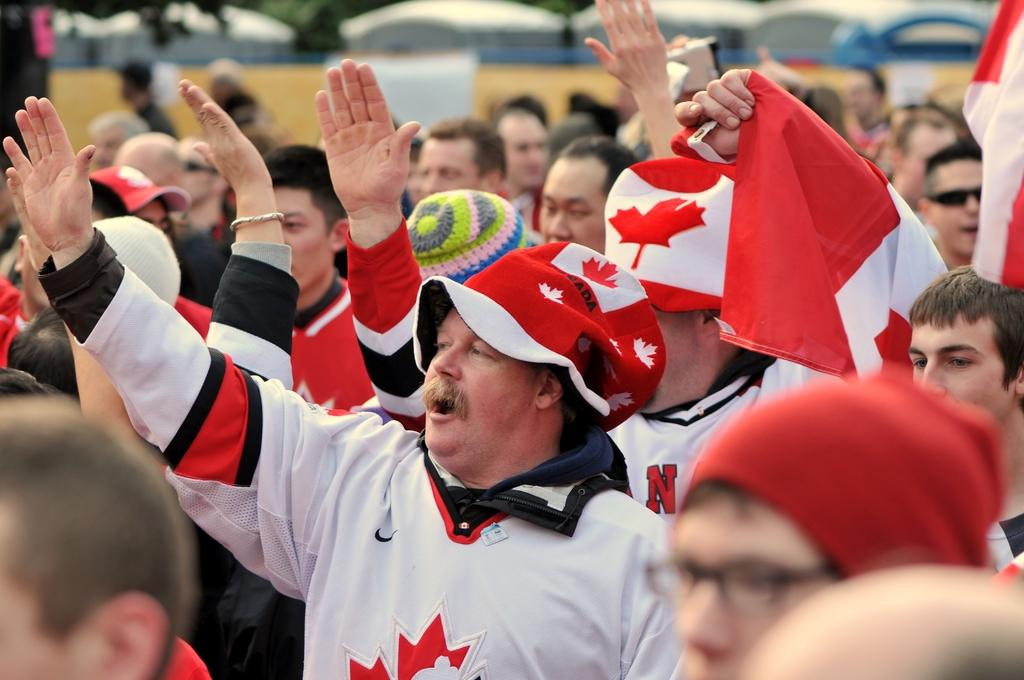Who or what can be seen in the image? There are people in the image. What is visible in the background of the image? There is a wall in the background of the image. What type of temporary shelter is present in the image? There are tents in the image. What type of pies are being served at the peace rally in the image? There is no mention of pies or a peace rally in the image; it simply features people, a wall, and tents. 